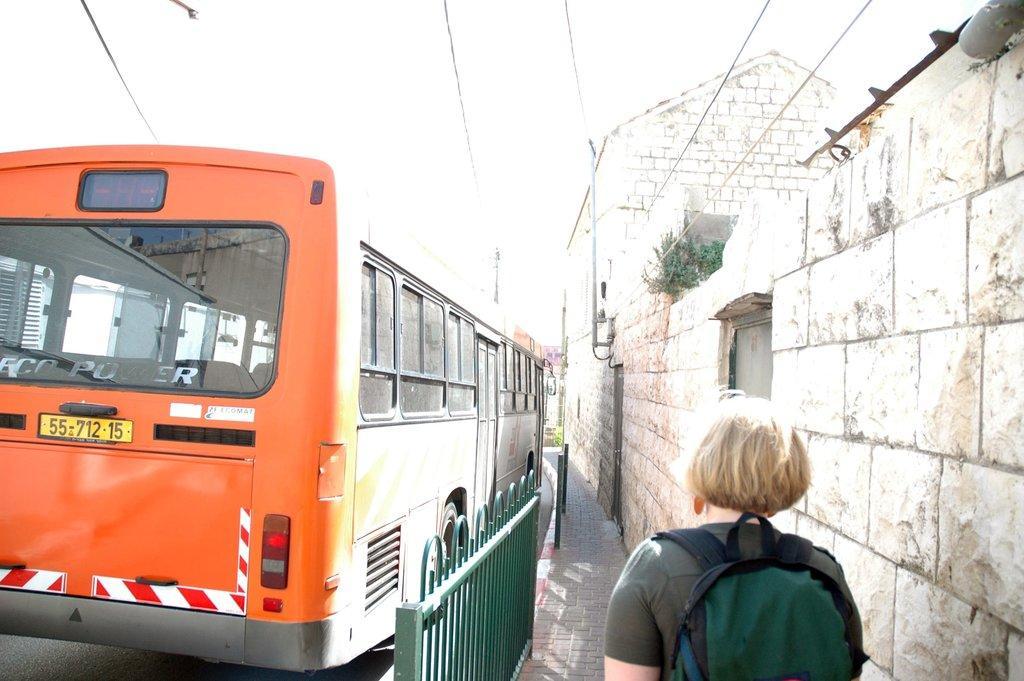How would you summarize this image in a sentence or two? In this picture I can observe a person walking on the footpath. I can observe a railing which is in green color in the bottom of the picture. In the middle of the picture there is an orange color bus on the road. In the background I can observe sky. 